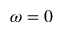<formula> <loc_0><loc_0><loc_500><loc_500>\omega = 0</formula> 